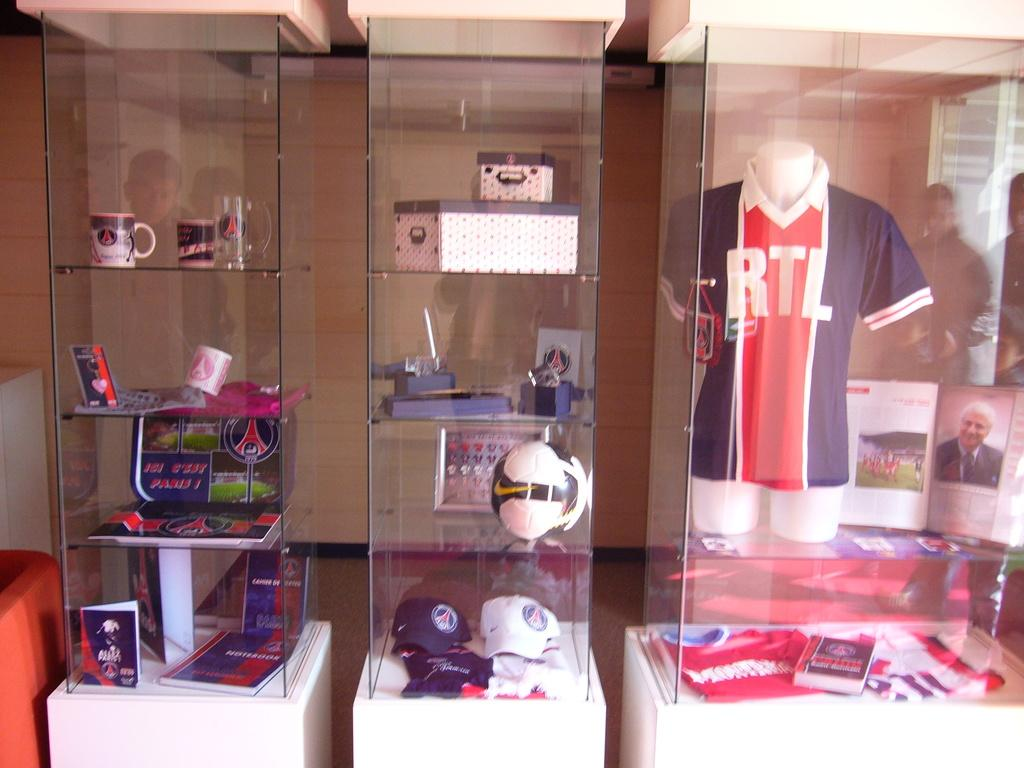<image>
Relay a brief, clear account of the picture shown. RTL Logo on a jersey in a glass window 